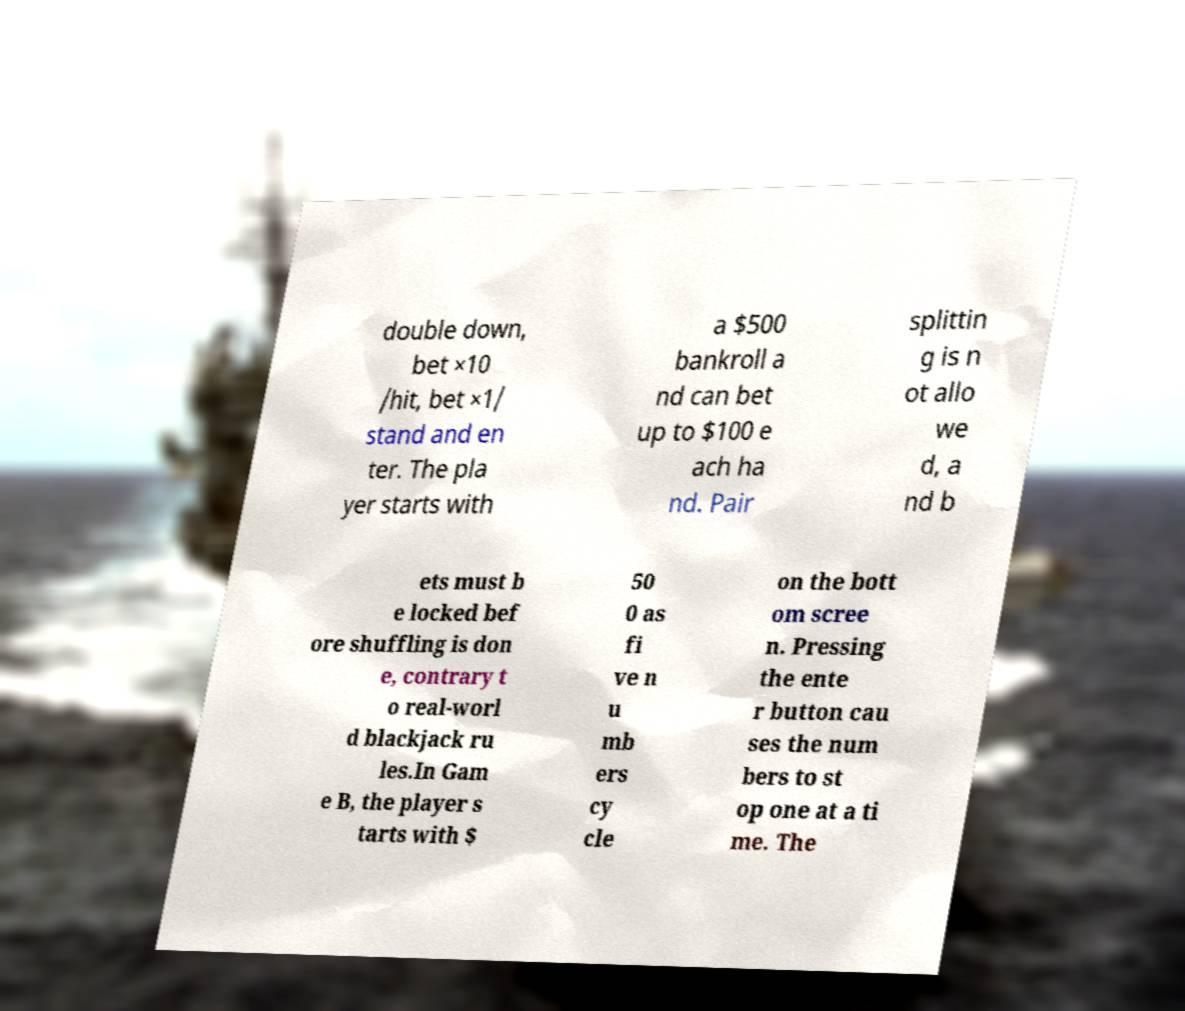I need the written content from this picture converted into text. Can you do that? double down, bet ×10 /hit, bet ×1/ stand and en ter. The pla yer starts with a $500 bankroll a nd can bet up to $100 e ach ha nd. Pair splittin g is n ot allo we d, a nd b ets must b e locked bef ore shuffling is don e, contrary t o real-worl d blackjack ru les.In Gam e B, the player s tarts with $ 50 0 as fi ve n u mb ers cy cle on the bott om scree n. Pressing the ente r button cau ses the num bers to st op one at a ti me. The 